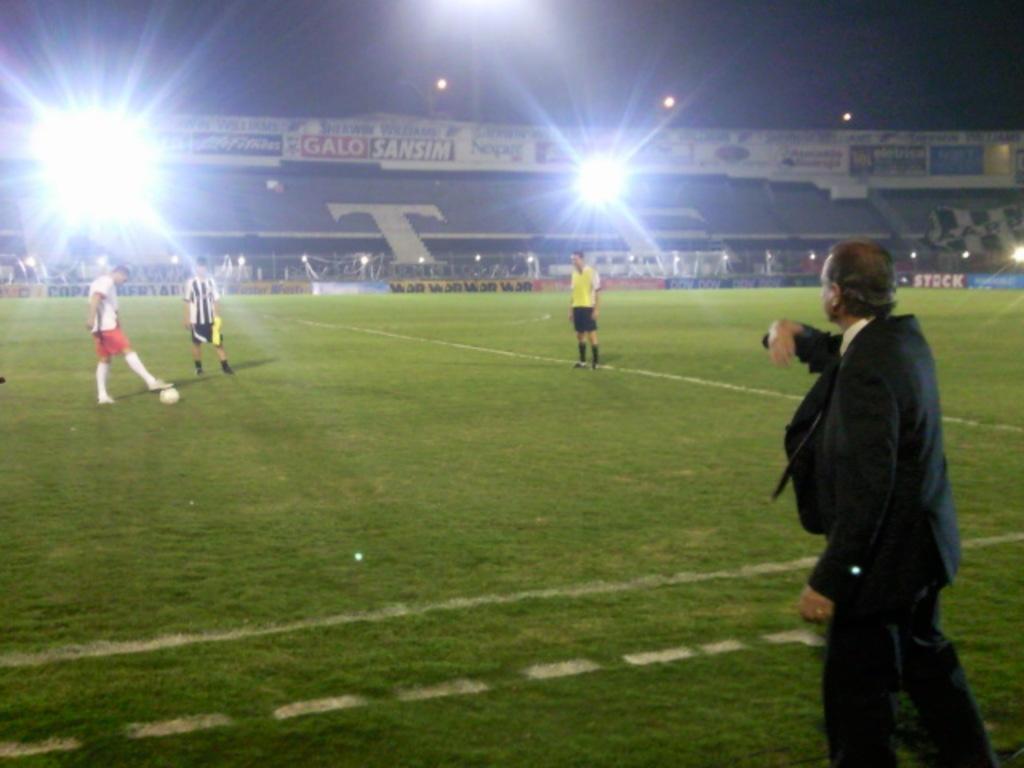What sponsor is in red and white lettering?
Your answer should be very brief. Galo. What letter is on the stands in white and very large?
Ensure brevity in your answer.  T. 